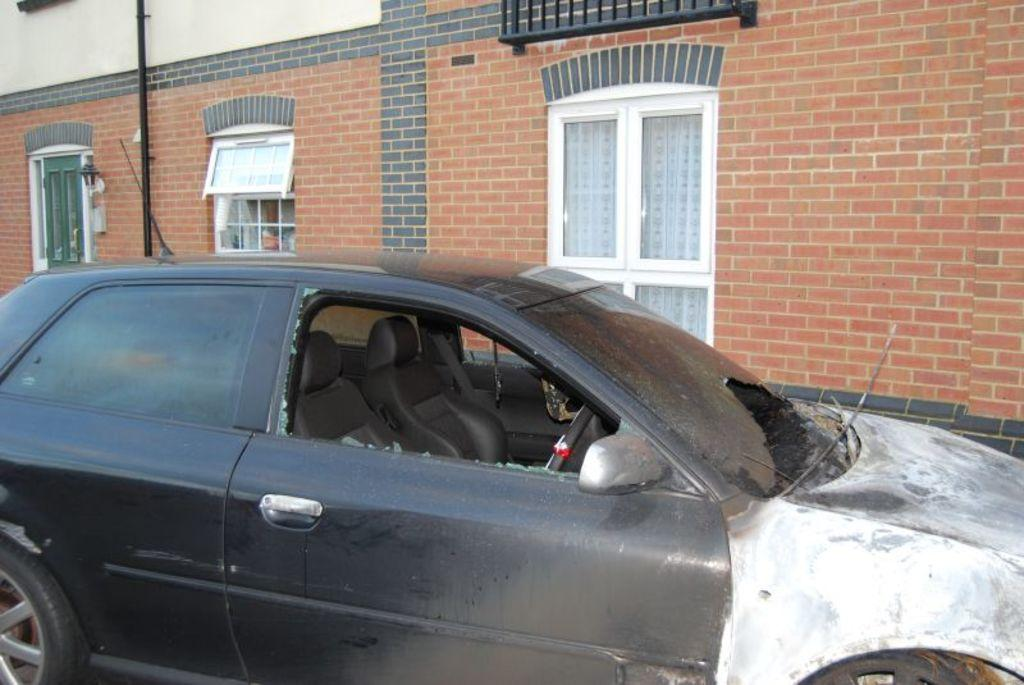What type of structure is visible in the image? There is a building with windows in the image. What is located in front of the building? There is a pole and a black vehicle in front of the building. Can you describe the garden and the farmer in the image? There is no garden or farmer present in the image. 